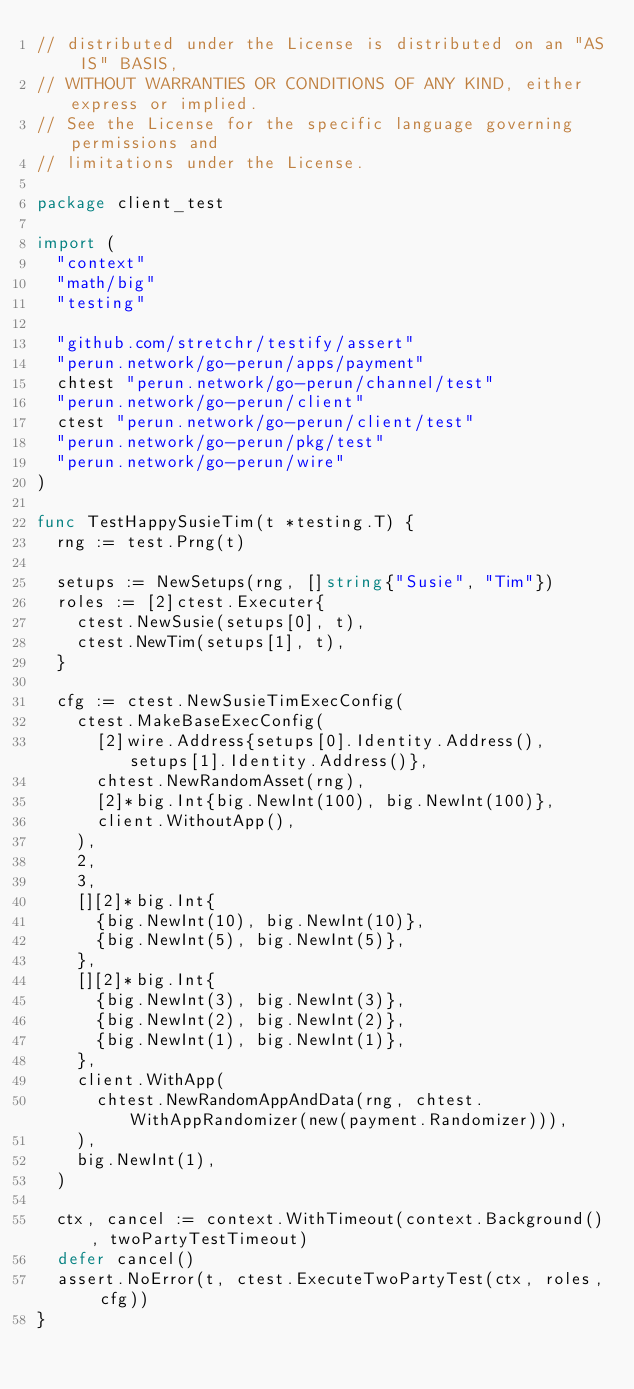Convert code to text. <code><loc_0><loc_0><loc_500><loc_500><_Go_>// distributed under the License is distributed on an "AS IS" BASIS,
// WITHOUT WARRANTIES OR CONDITIONS OF ANY KIND, either express or implied.
// See the License for the specific language governing permissions and
// limitations under the License.

package client_test

import (
	"context"
	"math/big"
	"testing"

	"github.com/stretchr/testify/assert"
	"perun.network/go-perun/apps/payment"
	chtest "perun.network/go-perun/channel/test"
	"perun.network/go-perun/client"
	ctest "perun.network/go-perun/client/test"
	"perun.network/go-perun/pkg/test"
	"perun.network/go-perun/wire"
)

func TestHappySusieTim(t *testing.T) {
	rng := test.Prng(t)

	setups := NewSetups(rng, []string{"Susie", "Tim"})
	roles := [2]ctest.Executer{
		ctest.NewSusie(setups[0], t),
		ctest.NewTim(setups[1], t),
	}

	cfg := ctest.NewSusieTimExecConfig(
		ctest.MakeBaseExecConfig(
			[2]wire.Address{setups[0].Identity.Address(), setups[1].Identity.Address()},
			chtest.NewRandomAsset(rng),
			[2]*big.Int{big.NewInt(100), big.NewInt(100)},
			client.WithoutApp(),
		),
		2,
		3,
		[][2]*big.Int{
			{big.NewInt(10), big.NewInt(10)},
			{big.NewInt(5), big.NewInt(5)},
		},
		[][2]*big.Int{
			{big.NewInt(3), big.NewInt(3)},
			{big.NewInt(2), big.NewInt(2)},
			{big.NewInt(1), big.NewInt(1)},
		},
		client.WithApp(
			chtest.NewRandomAppAndData(rng, chtest.WithAppRandomizer(new(payment.Randomizer))),
		),
		big.NewInt(1),
	)

	ctx, cancel := context.WithTimeout(context.Background(), twoPartyTestTimeout)
	defer cancel()
	assert.NoError(t, ctest.ExecuteTwoPartyTest(ctx, roles, cfg))
}
</code> 